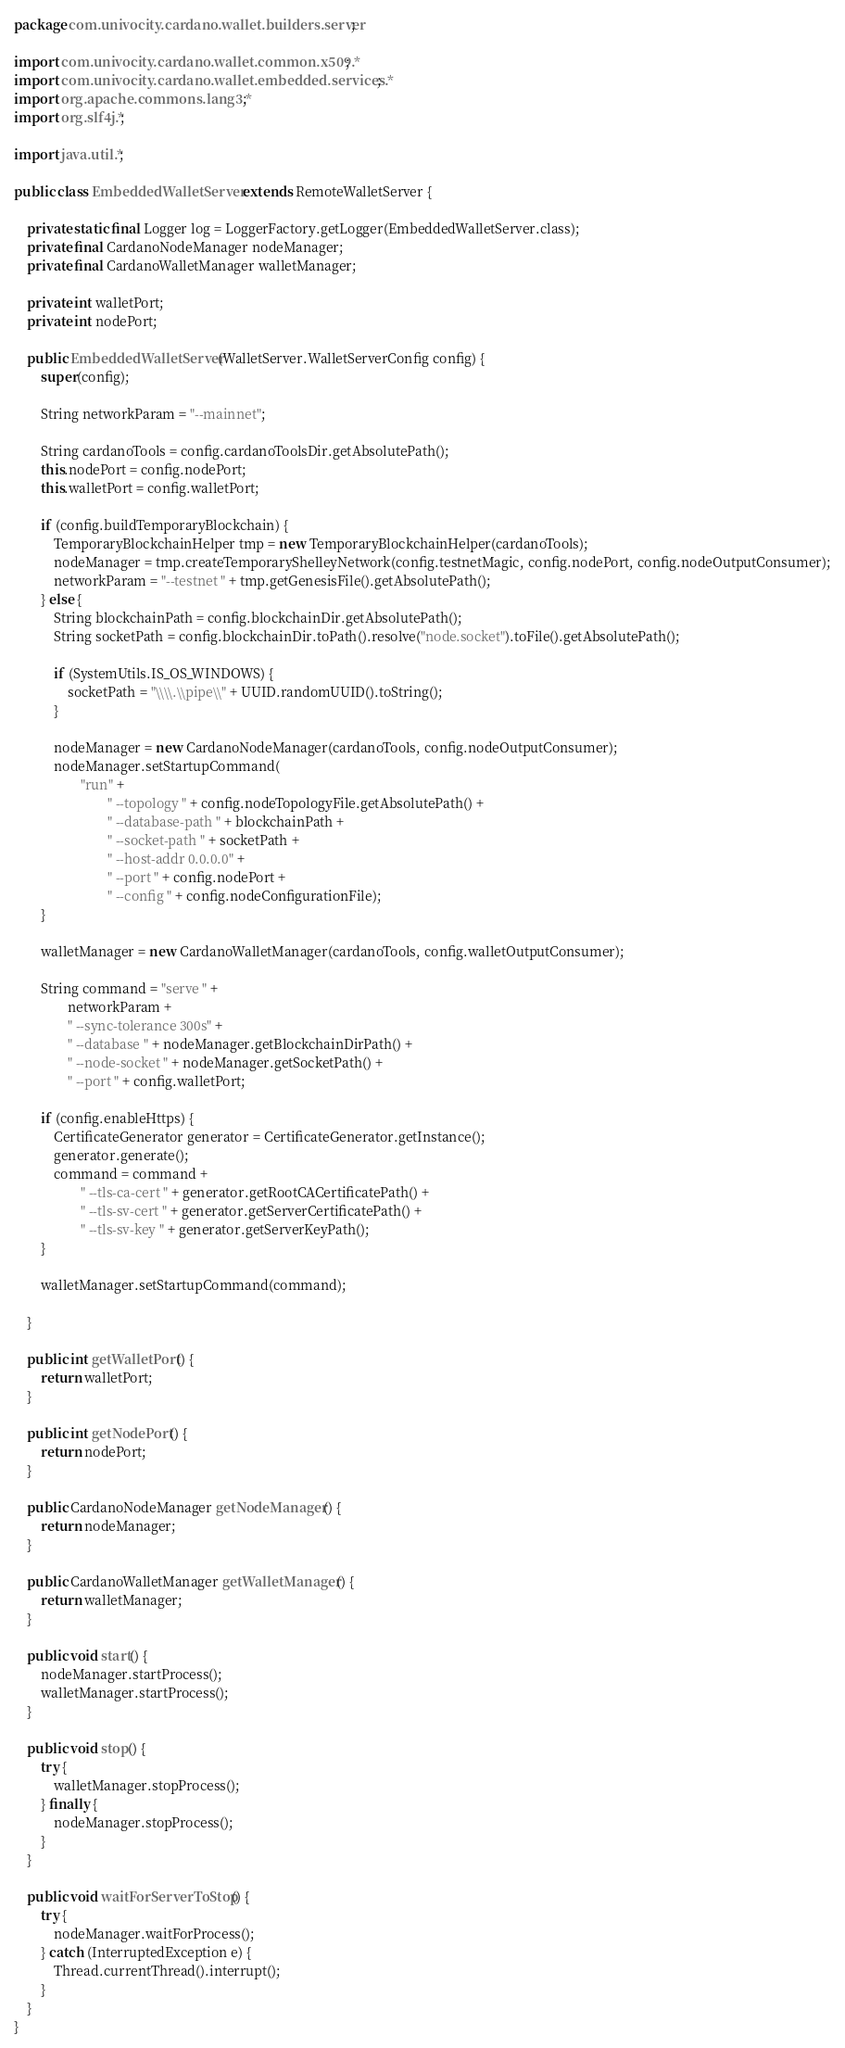Convert code to text. <code><loc_0><loc_0><loc_500><loc_500><_Java_>package com.univocity.cardano.wallet.builders.server;

import com.univocity.cardano.wallet.common.x509.*;
import com.univocity.cardano.wallet.embedded.services.*;
import org.apache.commons.lang3.*;
import org.slf4j.*;

import java.util.*;

public class EmbeddedWalletServer extends RemoteWalletServer {

	private static final Logger log = LoggerFactory.getLogger(EmbeddedWalletServer.class);
	private final CardanoNodeManager nodeManager;
	private final CardanoWalletManager walletManager;

	private int walletPort;
	private int nodePort;

	public EmbeddedWalletServer(WalletServer.WalletServerConfig config) {
		super(config);

		String networkParam = "--mainnet";

		String cardanoTools = config.cardanoToolsDir.getAbsolutePath();
		this.nodePort = config.nodePort;
		this.walletPort = config.walletPort;

		if (config.buildTemporaryBlockchain) {
			TemporaryBlockchainHelper tmp = new TemporaryBlockchainHelper(cardanoTools);
			nodeManager = tmp.createTemporaryShelleyNetwork(config.testnetMagic, config.nodePort, config.nodeOutputConsumer);
			networkParam = "--testnet " + tmp.getGenesisFile().getAbsolutePath();
		} else {
			String blockchainPath = config.blockchainDir.getAbsolutePath();
			String socketPath = config.blockchainDir.toPath().resolve("node.socket").toFile().getAbsolutePath();

			if (SystemUtils.IS_OS_WINDOWS) {
				socketPath = "\\\\.\\pipe\\" + UUID.randomUUID().toString();
			}

			nodeManager = new CardanoNodeManager(cardanoTools, config.nodeOutputConsumer);
			nodeManager.setStartupCommand(
					"run" +
							" --topology " + config.nodeTopologyFile.getAbsolutePath() +
							" --database-path " + blockchainPath +
							" --socket-path " + socketPath +
							" --host-addr 0.0.0.0" +
							" --port " + config.nodePort +
							" --config " + config.nodeConfigurationFile);
		}

		walletManager = new CardanoWalletManager(cardanoTools, config.walletOutputConsumer);

		String command = "serve " +
				networkParam +
				" --sync-tolerance 300s" +
				" --database " + nodeManager.getBlockchainDirPath() +
				" --node-socket " + nodeManager.getSocketPath() +
				" --port " + config.walletPort;

		if (config.enableHttps) {
			CertificateGenerator generator = CertificateGenerator.getInstance();
			generator.generate();
			command = command +
					" --tls-ca-cert " + generator.getRootCACertificatePath() +
					" --tls-sv-cert " + generator.getServerCertificatePath() +
					" --tls-sv-key " + generator.getServerKeyPath();
		}

		walletManager.setStartupCommand(command);

	}

	public int getWalletPort() {
		return walletPort;
	}

	public int getNodePort() {
		return nodePort;
	}

	public CardanoNodeManager getNodeManager() {
		return nodeManager;
	}

	public CardanoWalletManager getWalletManager() {
		return walletManager;
	}

	public void start() {
		nodeManager.startProcess();
		walletManager.startProcess();
	}

	public void stop() {
		try {
			walletManager.stopProcess();
		} finally {
			nodeManager.stopProcess();
		}
	}

	public void waitForServerToStop() {
		try {
			nodeManager.waitForProcess();
		} catch (InterruptedException e) {
			Thread.currentThread().interrupt();
		}
	}
}
</code> 